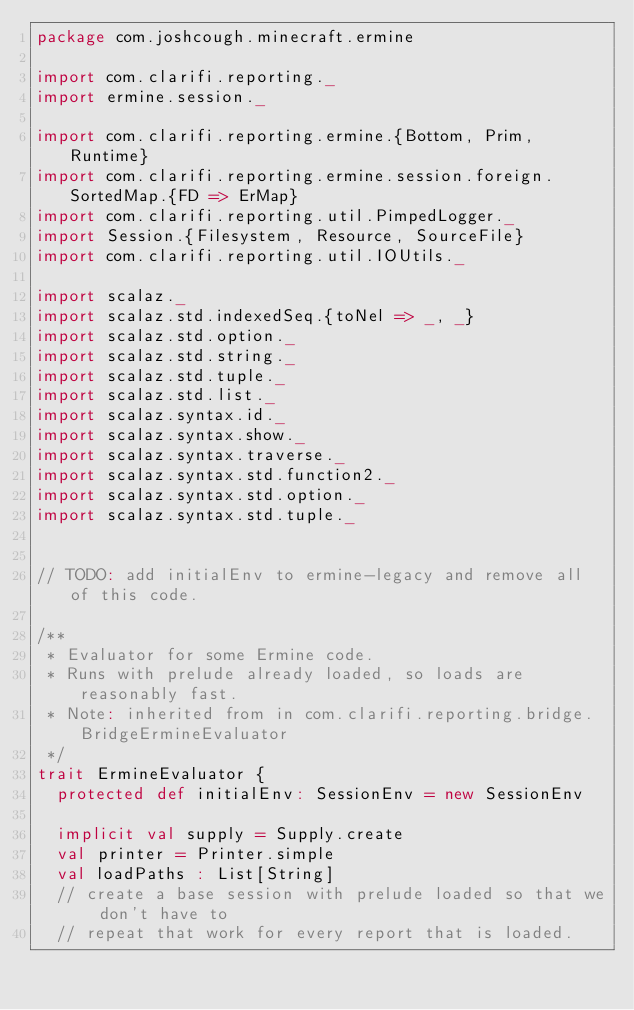Convert code to text. <code><loc_0><loc_0><loc_500><loc_500><_Scala_>package com.joshcough.minecraft.ermine

import com.clarifi.reporting._
import ermine.session._

import com.clarifi.reporting.ermine.{Bottom, Prim, Runtime}
import com.clarifi.reporting.ermine.session.foreign.SortedMap.{FD => ErMap}
import com.clarifi.reporting.util.PimpedLogger._
import Session.{Filesystem, Resource, SourceFile}
import com.clarifi.reporting.util.IOUtils._

import scalaz._
import scalaz.std.indexedSeq.{toNel => _, _}
import scalaz.std.option._
import scalaz.std.string._
import scalaz.std.tuple._
import scalaz.std.list._
import scalaz.syntax.id._
import scalaz.syntax.show._
import scalaz.syntax.traverse._
import scalaz.syntax.std.function2._
import scalaz.syntax.std.option._
import scalaz.syntax.std.tuple._


// TODO: add initialEnv to ermine-legacy and remove all of this code.

/**
 * Evaluator for some Ermine code.
 * Runs with prelude already loaded, so loads are reasonably fast.
 * Note: inherited from in com.clarifi.reporting.bridge.BridgeErmineEvaluator
 */
trait ErmineEvaluator {
  protected def initialEnv: SessionEnv = new SessionEnv

  implicit val supply = Supply.create
  val printer = Printer.simple
  val loadPaths : List[String]
  // create a base session with prelude loaded so that we don't have to
  // repeat that work for every report that is loaded.</code> 